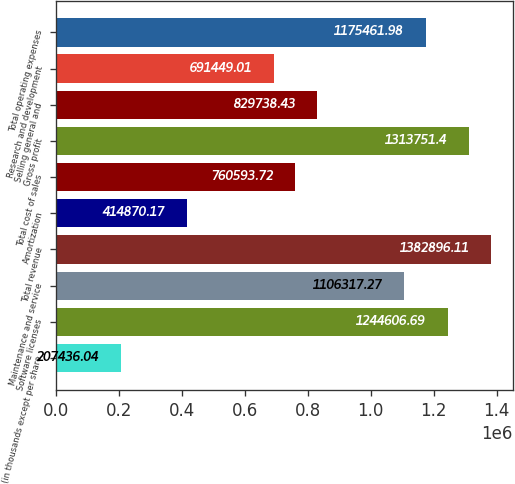<chart> <loc_0><loc_0><loc_500><loc_500><bar_chart><fcel>(in thousands except per share<fcel>Software licenses<fcel>Maintenance and service<fcel>Total revenue<fcel>Amortization<fcel>Total cost of sales<fcel>Gross profit<fcel>Selling general and<fcel>Research and development<fcel>Total operating expenses<nl><fcel>207436<fcel>1.24461e+06<fcel>1.10632e+06<fcel>1.3829e+06<fcel>414870<fcel>760594<fcel>1.31375e+06<fcel>829738<fcel>691449<fcel>1.17546e+06<nl></chart> 